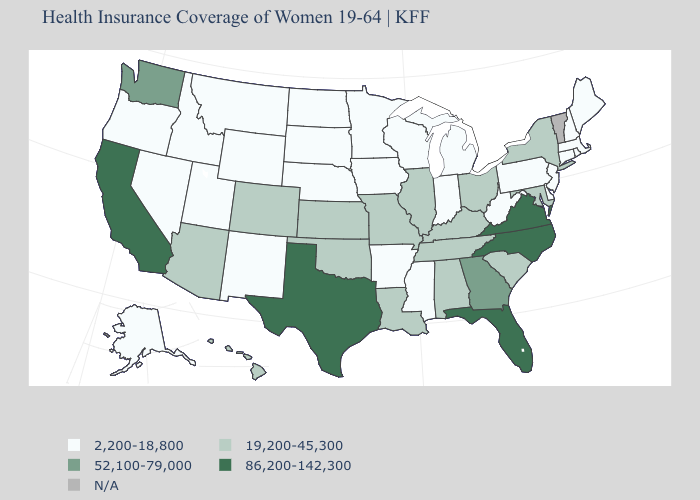Which states have the lowest value in the USA?
Concise answer only. Alaska, Arkansas, Connecticut, Delaware, Idaho, Indiana, Iowa, Maine, Massachusetts, Michigan, Minnesota, Mississippi, Montana, Nebraska, Nevada, New Hampshire, New Jersey, New Mexico, North Dakota, Oregon, Pennsylvania, Rhode Island, South Dakota, Utah, West Virginia, Wisconsin, Wyoming. What is the value of Georgia?
Be succinct. 52,100-79,000. Does North Carolina have the highest value in the South?
Keep it brief. Yes. What is the lowest value in the MidWest?
Give a very brief answer. 2,200-18,800. Name the states that have a value in the range 19,200-45,300?
Be succinct. Alabama, Arizona, Colorado, Hawaii, Illinois, Kansas, Kentucky, Louisiana, Maryland, Missouri, New York, Ohio, Oklahoma, South Carolina, Tennessee. What is the value of Connecticut?
Short answer required. 2,200-18,800. Name the states that have a value in the range 86,200-142,300?
Keep it brief. California, Florida, North Carolina, Texas, Virginia. What is the value of Wyoming?
Be succinct. 2,200-18,800. How many symbols are there in the legend?
Keep it brief. 5. Does the map have missing data?
Give a very brief answer. Yes. Does South Carolina have the highest value in the South?
Quick response, please. No. Does Colorado have the lowest value in the USA?
Answer briefly. No. Does the map have missing data?
Short answer required. Yes. Does Oklahoma have the lowest value in the South?
Write a very short answer. No. 